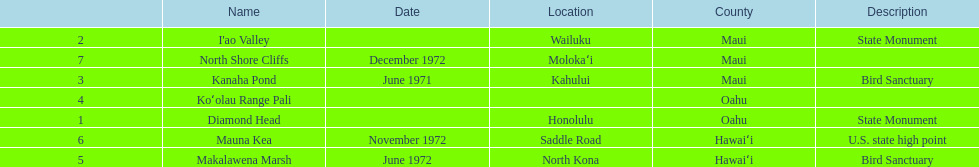How many dates are in 1972? 3. 